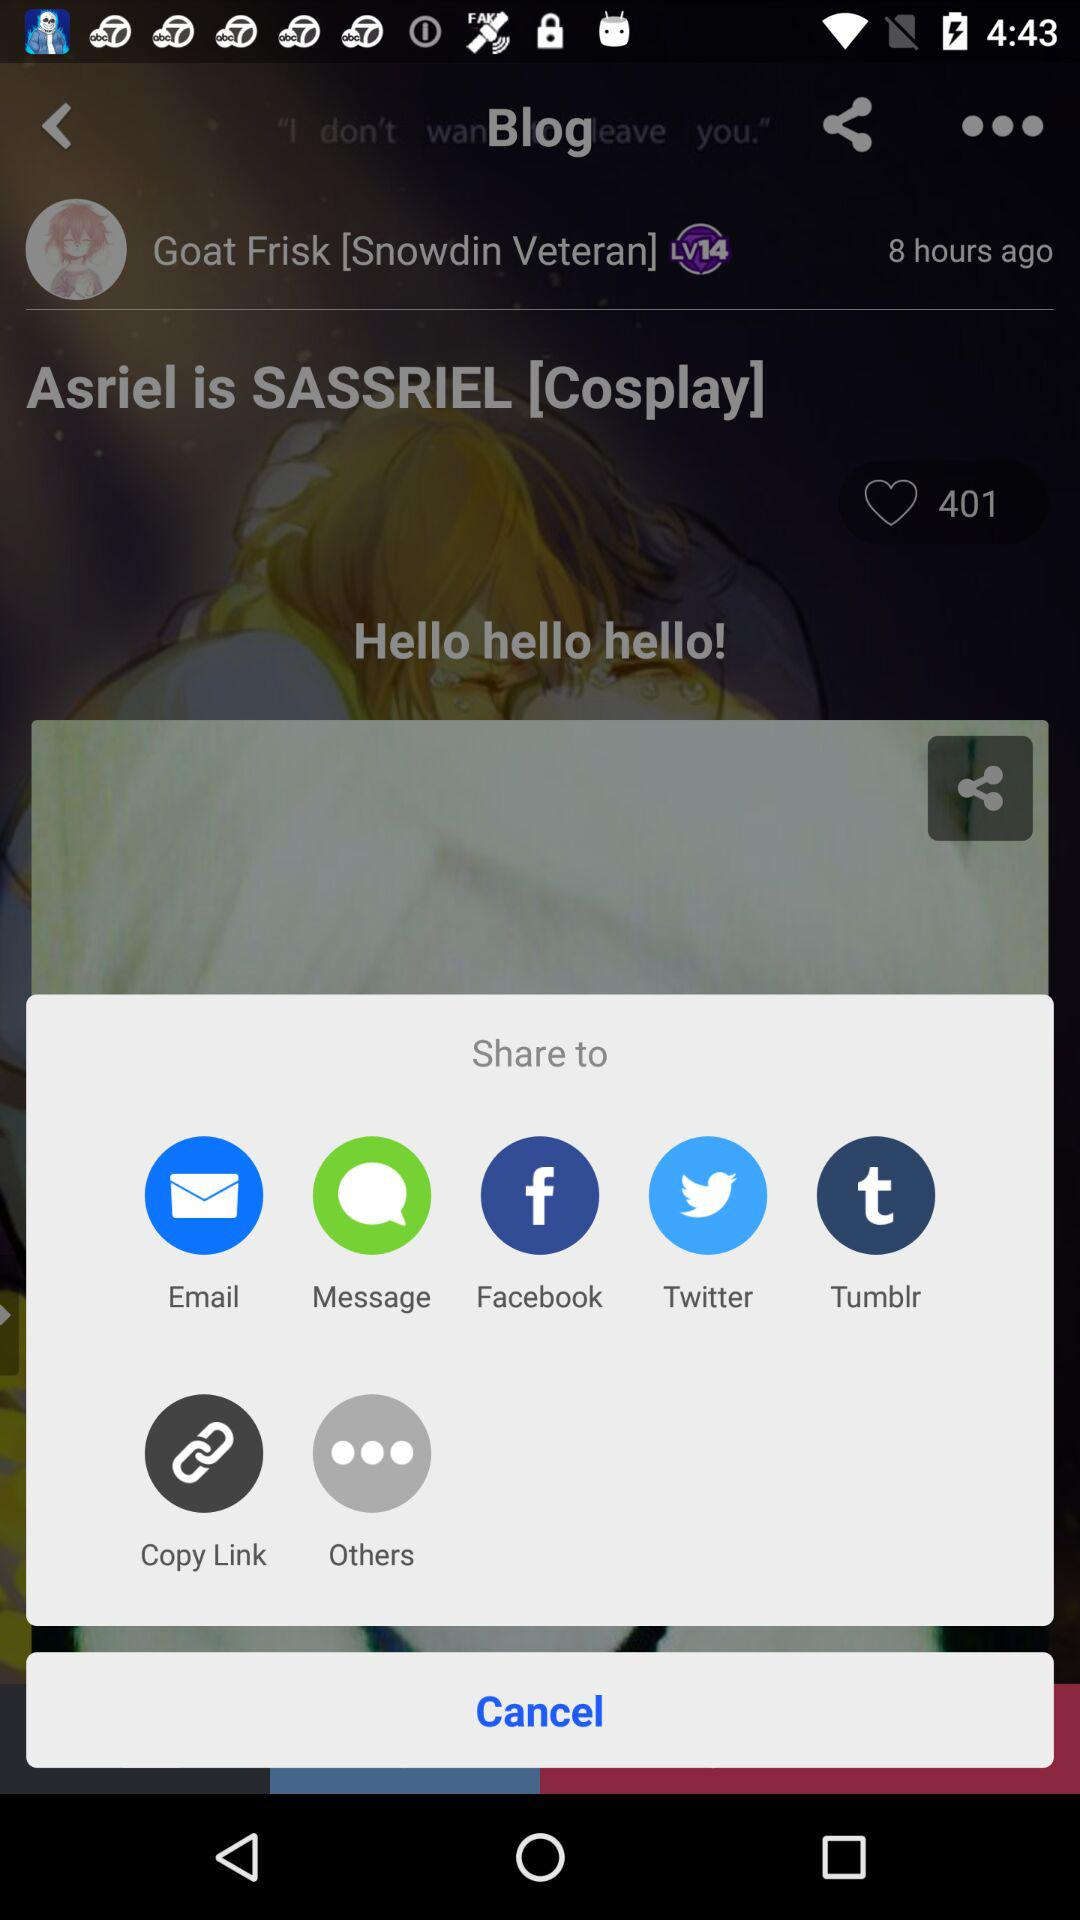What are the options available for sharing? The options available for sharing are "Email", "Message", "Facebook", "Twitter" and "Tumblr". 